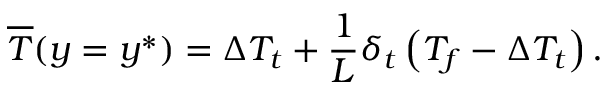Convert formula to latex. <formula><loc_0><loc_0><loc_500><loc_500>\overline { T } ( y = y ^ { * } ) = \Delta T _ { t } + \frac { 1 } { L } \delta _ { t } \left ( T _ { f } - \Delta T _ { t } \right ) .</formula> 